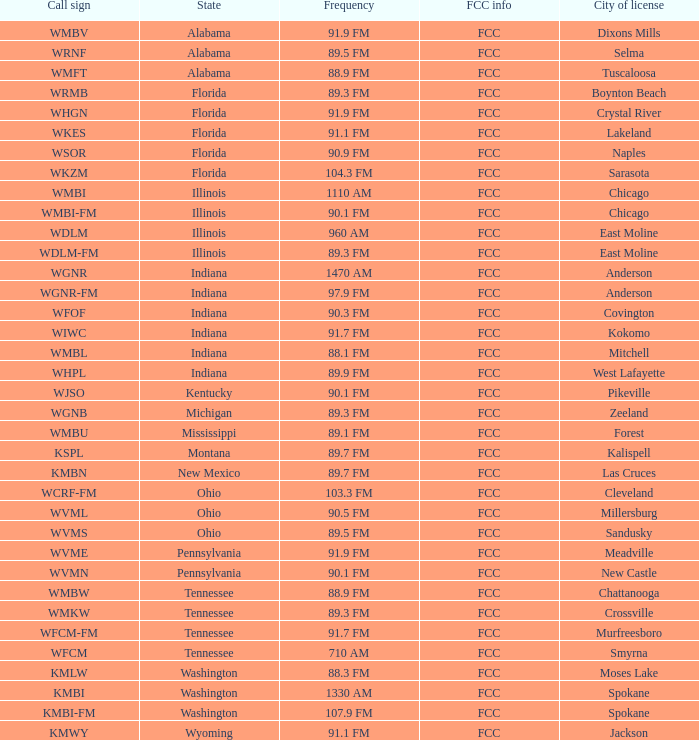What state is the radio station in that has a frequency of 90.1 FM and a city license in New Castle? Pennsylvania. 